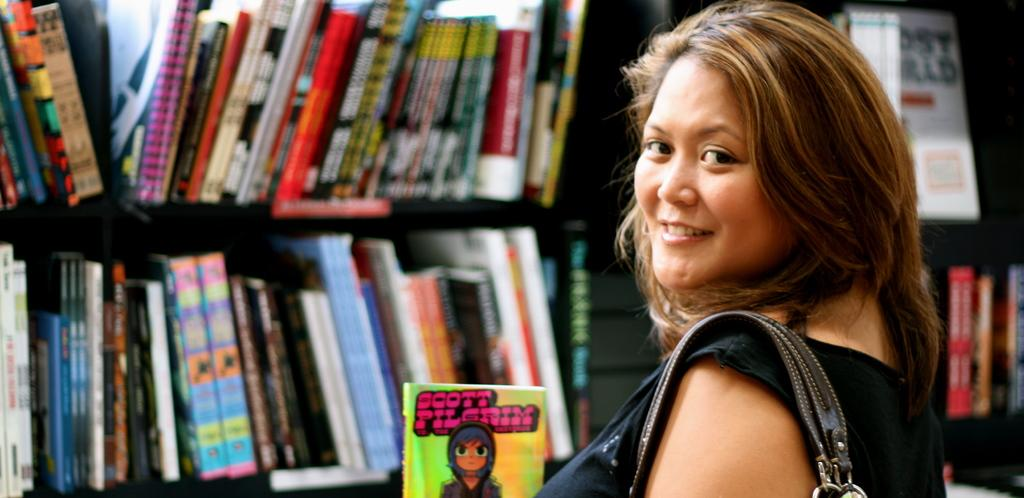<image>
Relay a brief, clear account of the picture shown. Woman holding a purse standing in front ofa Scott Pilgrim bookk. 